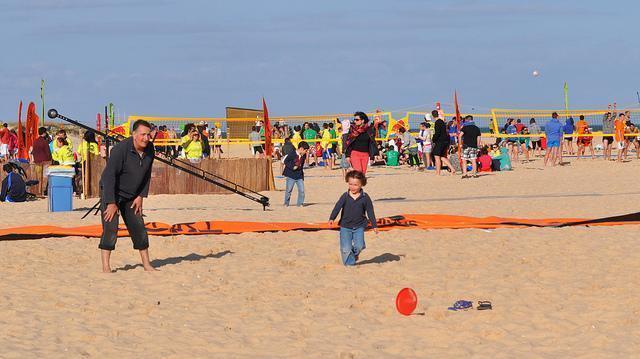What do they want to prevent the ball from touching?
From the following set of four choices, select the accurate answer to respond to the question.
Options: Grass, sand, people, net. Sand. 